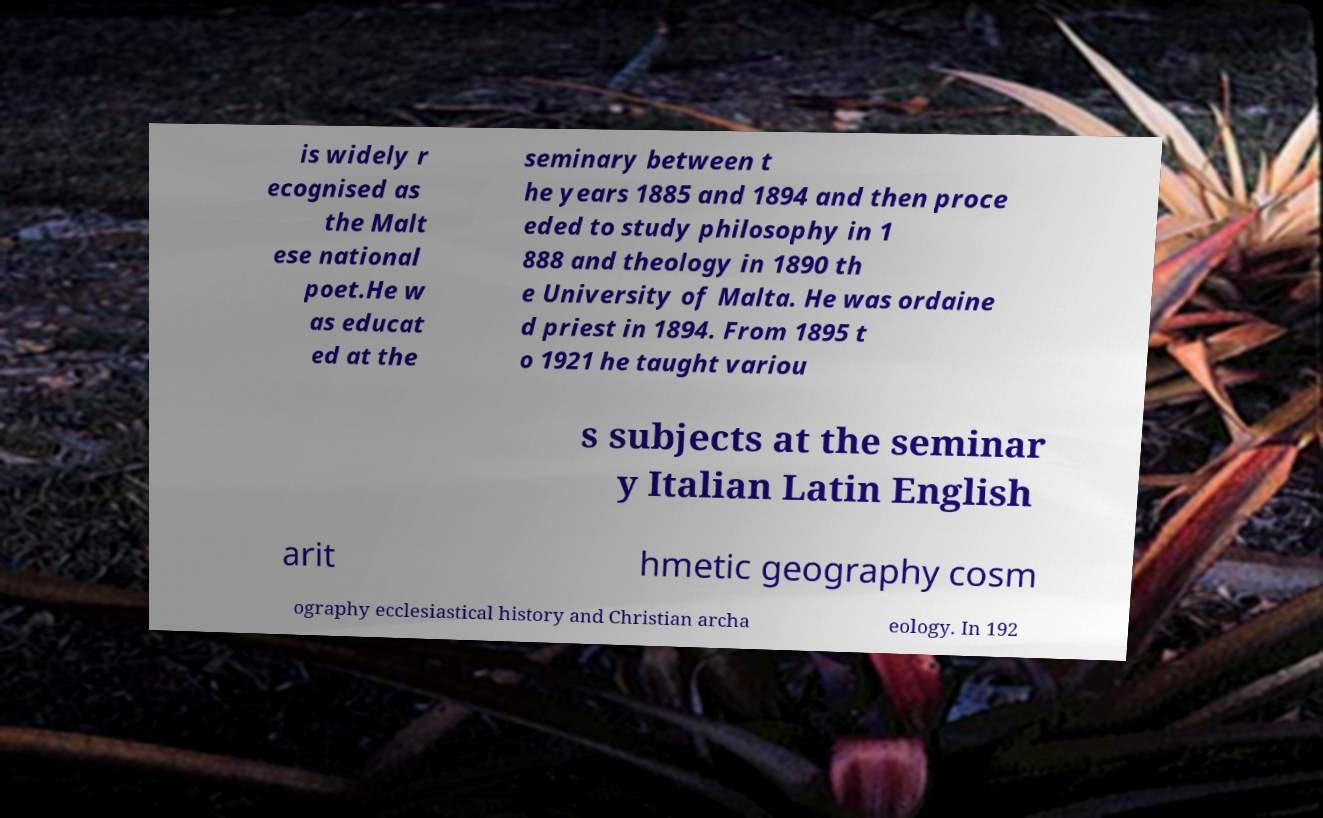Can you accurately transcribe the text from the provided image for me? is widely r ecognised as the Malt ese national poet.He w as educat ed at the seminary between t he years 1885 and 1894 and then proce eded to study philosophy in 1 888 and theology in 1890 th e University of Malta. He was ordaine d priest in 1894. From 1895 t o 1921 he taught variou s subjects at the seminar y Italian Latin English arit hmetic geography cosm ography ecclesiastical history and Christian archa eology. In 192 